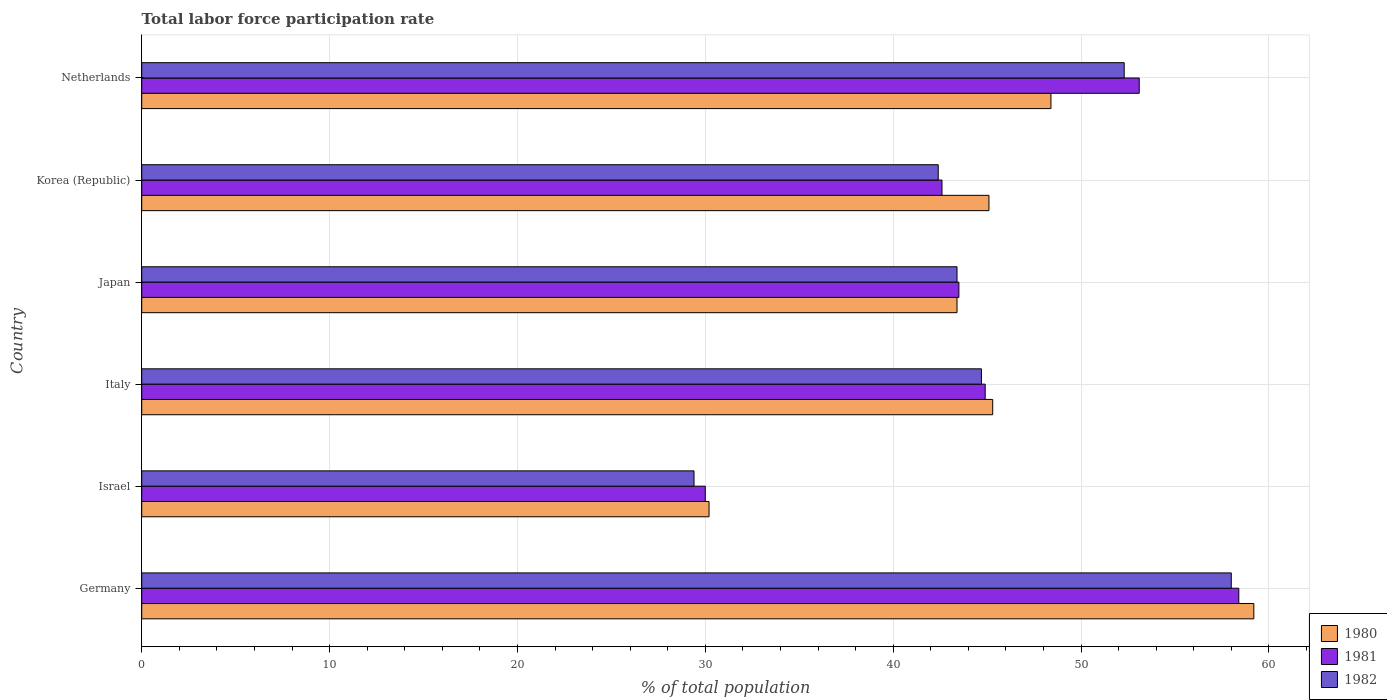How many different coloured bars are there?
Keep it short and to the point. 3. What is the total labor force participation rate in 1982 in Netherlands?
Keep it short and to the point. 52.3. Across all countries, what is the minimum total labor force participation rate in 1980?
Offer a terse response. 30.2. In which country was the total labor force participation rate in 1981 minimum?
Provide a short and direct response. Israel. What is the total total labor force participation rate in 1980 in the graph?
Provide a succinct answer. 271.6. What is the difference between the total labor force participation rate in 1982 in Germany and that in Netherlands?
Keep it short and to the point. 5.7. What is the difference between the total labor force participation rate in 1980 in Israel and the total labor force participation rate in 1982 in Germany?
Your answer should be compact. -27.8. What is the average total labor force participation rate in 1982 per country?
Give a very brief answer. 45.03. What is the difference between the total labor force participation rate in 1982 and total labor force participation rate in 1980 in Israel?
Keep it short and to the point. -0.8. In how many countries, is the total labor force participation rate in 1981 greater than 20 %?
Your response must be concise. 6. What is the ratio of the total labor force participation rate in 1982 in Korea (Republic) to that in Netherlands?
Provide a succinct answer. 0.81. Is the total labor force participation rate in 1981 in Germany less than that in Italy?
Offer a very short reply. No. What is the difference between the highest and the second highest total labor force participation rate in 1981?
Your answer should be compact. 5.3. What is the difference between the highest and the lowest total labor force participation rate in 1982?
Offer a very short reply. 28.6. Is the sum of the total labor force participation rate in 1981 in Germany and Italy greater than the maximum total labor force participation rate in 1980 across all countries?
Keep it short and to the point. Yes. How many countries are there in the graph?
Offer a terse response. 6. Are the values on the major ticks of X-axis written in scientific E-notation?
Your answer should be very brief. No. Does the graph contain any zero values?
Your answer should be compact. No. Where does the legend appear in the graph?
Offer a terse response. Bottom right. How many legend labels are there?
Provide a succinct answer. 3. What is the title of the graph?
Offer a terse response. Total labor force participation rate. What is the label or title of the X-axis?
Offer a terse response. % of total population. What is the % of total population of 1980 in Germany?
Your response must be concise. 59.2. What is the % of total population in 1981 in Germany?
Make the answer very short. 58.4. What is the % of total population of 1980 in Israel?
Provide a succinct answer. 30.2. What is the % of total population in 1982 in Israel?
Your answer should be very brief. 29.4. What is the % of total population in 1980 in Italy?
Make the answer very short. 45.3. What is the % of total population in 1981 in Italy?
Offer a terse response. 44.9. What is the % of total population of 1982 in Italy?
Offer a very short reply. 44.7. What is the % of total population of 1980 in Japan?
Your answer should be compact. 43.4. What is the % of total population in 1981 in Japan?
Provide a short and direct response. 43.5. What is the % of total population of 1982 in Japan?
Make the answer very short. 43.4. What is the % of total population in 1980 in Korea (Republic)?
Ensure brevity in your answer.  45.1. What is the % of total population of 1981 in Korea (Republic)?
Provide a succinct answer. 42.6. What is the % of total population in 1982 in Korea (Republic)?
Your answer should be very brief. 42.4. What is the % of total population of 1980 in Netherlands?
Offer a very short reply. 48.4. What is the % of total population of 1981 in Netherlands?
Provide a succinct answer. 53.1. What is the % of total population of 1982 in Netherlands?
Provide a succinct answer. 52.3. Across all countries, what is the maximum % of total population in 1980?
Offer a terse response. 59.2. Across all countries, what is the maximum % of total population of 1981?
Keep it short and to the point. 58.4. Across all countries, what is the minimum % of total population of 1980?
Your response must be concise. 30.2. Across all countries, what is the minimum % of total population of 1982?
Provide a succinct answer. 29.4. What is the total % of total population of 1980 in the graph?
Provide a short and direct response. 271.6. What is the total % of total population in 1981 in the graph?
Provide a short and direct response. 272.5. What is the total % of total population in 1982 in the graph?
Your answer should be compact. 270.2. What is the difference between the % of total population of 1980 in Germany and that in Israel?
Offer a very short reply. 29. What is the difference between the % of total population in 1981 in Germany and that in Israel?
Keep it short and to the point. 28.4. What is the difference between the % of total population of 1982 in Germany and that in Israel?
Offer a very short reply. 28.6. What is the difference between the % of total population in 1981 in Germany and that in Italy?
Your response must be concise. 13.5. What is the difference between the % of total population of 1982 in Germany and that in Italy?
Offer a very short reply. 13.3. What is the difference between the % of total population in 1981 in Germany and that in Japan?
Your response must be concise. 14.9. What is the difference between the % of total population of 1980 in Germany and that in Korea (Republic)?
Offer a very short reply. 14.1. What is the difference between the % of total population of 1980 in Germany and that in Netherlands?
Your answer should be compact. 10.8. What is the difference between the % of total population in 1981 in Germany and that in Netherlands?
Make the answer very short. 5.3. What is the difference between the % of total population in 1980 in Israel and that in Italy?
Give a very brief answer. -15.1. What is the difference between the % of total population of 1981 in Israel and that in Italy?
Provide a succinct answer. -14.9. What is the difference between the % of total population of 1982 in Israel and that in Italy?
Make the answer very short. -15.3. What is the difference between the % of total population in 1981 in Israel and that in Japan?
Your answer should be very brief. -13.5. What is the difference between the % of total population of 1982 in Israel and that in Japan?
Keep it short and to the point. -14. What is the difference between the % of total population of 1980 in Israel and that in Korea (Republic)?
Provide a short and direct response. -14.9. What is the difference between the % of total population in 1981 in Israel and that in Korea (Republic)?
Your answer should be compact. -12.6. What is the difference between the % of total population of 1980 in Israel and that in Netherlands?
Your response must be concise. -18.2. What is the difference between the % of total population of 1981 in Israel and that in Netherlands?
Your answer should be compact. -23.1. What is the difference between the % of total population of 1982 in Israel and that in Netherlands?
Make the answer very short. -22.9. What is the difference between the % of total population of 1981 in Italy and that in Japan?
Offer a very short reply. 1.4. What is the difference between the % of total population in 1982 in Italy and that in Japan?
Provide a succinct answer. 1.3. What is the difference between the % of total population in 1980 in Italy and that in Korea (Republic)?
Offer a very short reply. 0.2. What is the difference between the % of total population in 1981 in Italy and that in Korea (Republic)?
Make the answer very short. 2.3. What is the difference between the % of total population in 1982 in Italy and that in Korea (Republic)?
Ensure brevity in your answer.  2.3. What is the difference between the % of total population in 1980 in Italy and that in Netherlands?
Give a very brief answer. -3.1. What is the difference between the % of total population in 1981 in Italy and that in Netherlands?
Give a very brief answer. -8.2. What is the difference between the % of total population of 1982 in Japan and that in Korea (Republic)?
Your response must be concise. 1. What is the difference between the % of total population of 1980 in Japan and that in Netherlands?
Your answer should be compact. -5. What is the difference between the % of total population in 1982 in Japan and that in Netherlands?
Make the answer very short. -8.9. What is the difference between the % of total population of 1980 in Germany and the % of total population of 1981 in Israel?
Keep it short and to the point. 29.2. What is the difference between the % of total population in 1980 in Germany and the % of total population in 1982 in Israel?
Your answer should be compact. 29.8. What is the difference between the % of total population in 1980 in Germany and the % of total population in 1981 in Italy?
Your response must be concise. 14.3. What is the difference between the % of total population of 1980 in Germany and the % of total population of 1982 in Italy?
Make the answer very short. 14.5. What is the difference between the % of total population of 1980 in Germany and the % of total population of 1981 in Japan?
Offer a terse response. 15.7. What is the difference between the % of total population of 1980 in Germany and the % of total population of 1982 in Japan?
Ensure brevity in your answer.  15.8. What is the difference between the % of total population in 1980 in Germany and the % of total population in 1981 in Korea (Republic)?
Make the answer very short. 16.6. What is the difference between the % of total population in 1980 in Germany and the % of total population in 1982 in Korea (Republic)?
Provide a succinct answer. 16.8. What is the difference between the % of total population of 1980 in Germany and the % of total population of 1981 in Netherlands?
Ensure brevity in your answer.  6.1. What is the difference between the % of total population in 1980 in Israel and the % of total population in 1981 in Italy?
Provide a short and direct response. -14.7. What is the difference between the % of total population of 1981 in Israel and the % of total population of 1982 in Italy?
Provide a succinct answer. -14.7. What is the difference between the % of total population in 1980 in Israel and the % of total population in 1981 in Japan?
Offer a terse response. -13.3. What is the difference between the % of total population of 1980 in Israel and the % of total population of 1982 in Japan?
Give a very brief answer. -13.2. What is the difference between the % of total population of 1980 in Israel and the % of total population of 1981 in Korea (Republic)?
Your answer should be compact. -12.4. What is the difference between the % of total population in 1981 in Israel and the % of total population in 1982 in Korea (Republic)?
Offer a very short reply. -12.4. What is the difference between the % of total population of 1980 in Israel and the % of total population of 1981 in Netherlands?
Keep it short and to the point. -22.9. What is the difference between the % of total population of 1980 in Israel and the % of total population of 1982 in Netherlands?
Your answer should be very brief. -22.1. What is the difference between the % of total population of 1981 in Israel and the % of total population of 1982 in Netherlands?
Your response must be concise. -22.3. What is the difference between the % of total population of 1980 in Italy and the % of total population of 1982 in Japan?
Provide a short and direct response. 1.9. What is the difference between the % of total population in 1980 in Italy and the % of total population in 1982 in Korea (Republic)?
Offer a very short reply. 2.9. What is the difference between the % of total population of 1980 in Italy and the % of total population of 1981 in Netherlands?
Provide a short and direct response. -7.8. What is the difference between the % of total population in 1981 in Italy and the % of total population in 1982 in Netherlands?
Ensure brevity in your answer.  -7.4. What is the difference between the % of total population in 1980 in Japan and the % of total population in 1982 in Korea (Republic)?
Provide a succinct answer. 1. What is the difference between the % of total population in 1980 in Japan and the % of total population in 1981 in Netherlands?
Make the answer very short. -9.7. What is the difference between the % of total population of 1980 in Japan and the % of total population of 1982 in Netherlands?
Offer a very short reply. -8.9. What is the difference between the % of total population of 1980 in Korea (Republic) and the % of total population of 1982 in Netherlands?
Give a very brief answer. -7.2. What is the difference between the % of total population of 1981 in Korea (Republic) and the % of total population of 1982 in Netherlands?
Offer a terse response. -9.7. What is the average % of total population in 1980 per country?
Provide a succinct answer. 45.27. What is the average % of total population of 1981 per country?
Give a very brief answer. 45.42. What is the average % of total population in 1982 per country?
Ensure brevity in your answer.  45.03. What is the difference between the % of total population of 1980 and % of total population of 1981 in Germany?
Your response must be concise. 0.8. What is the difference between the % of total population in 1980 and % of total population in 1982 in Germany?
Give a very brief answer. 1.2. What is the difference between the % of total population of 1981 and % of total population of 1982 in Germany?
Your answer should be very brief. 0.4. What is the difference between the % of total population in 1980 and % of total population in 1982 in Israel?
Provide a short and direct response. 0.8. What is the difference between the % of total population in 1980 and % of total population in 1981 in Italy?
Provide a short and direct response. 0.4. What is the difference between the % of total population in 1980 and % of total population in 1982 in Italy?
Keep it short and to the point. 0.6. What is the difference between the % of total population of 1980 and % of total population of 1982 in Japan?
Provide a short and direct response. 0. What is the difference between the % of total population in 1980 and % of total population in 1982 in Korea (Republic)?
Provide a short and direct response. 2.7. What is the difference between the % of total population of 1980 and % of total population of 1981 in Netherlands?
Keep it short and to the point. -4.7. What is the ratio of the % of total population in 1980 in Germany to that in Israel?
Your answer should be compact. 1.96. What is the ratio of the % of total population in 1981 in Germany to that in Israel?
Provide a short and direct response. 1.95. What is the ratio of the % of total population of 1982 in Germany to that in Israel?
Keep it short and to the point. 1.97. What is the ratio of the % of total population of 1980 in Germany to that in Italy?
Your answer should be very brief. 1.31. What is the ratio of the % of total population in 1981 in Germany to that in Italy?
Your response must be concise. 1.3. What is the ratio of the % of total population in 1982 in Germany to that in Italy?
Offer a terse response. 1.3. What is the ratio of the % of total population in 1980 in Germany to that in Japan?
Provide a succinct answer. 1.36. What is the ratio of the % of total population of 1981 in Germany to that in Japan?
Provide a short and direct response. 1.34. What is the ratio of the % of total population of 1982 in Germany to that in Japan?
Give a very brief answer. 1.34. What is the ratio of the % of total population in 1980 in Germany to that in Korea (Republic)?
Provide a succinct answer. 1.31. What is the ratio of the % of total population of 1981 in Germany to that in Korea (Republic)?
Your response must be concise. 1.37. What is the ratio of the % of total population in 1982 in Germany to that in Korea (Republic)?
Keep it short and to the point. 1.37. What is the ratio of the % of total population of 1980 in Germany to that in Netherlands?
Keep it short and to the point. 1.22. What is the ratio of the % of total population of 1981 in Germany to that in Netherlands?
Provide a succinct answer. 1.1. What is the ratio of the % of total population of 1982 in Germany to that in Netherlands?
Keep it short and to the point. 1.11. What is the ratio of the % of total population in 1980 in Israel to that in Italy?
Keep it short and to the point. 0.67. What is the ratio of the % of total population in 1981 in Israel to that in Italy?
Make the answer very short. 0.67. What is the ratio of the % of total population of 1982 in Israel to that in Italy?
Give a very brief answer. 0.66. What is the ratio of the % of total population in 1980 in Israel to that in Japan?
Your answer should be very brief. 0.7. What is the ratio of the % of total population of 1981 in Israel to that in Japan?
Offer a terse response. 0.69. What is the ratio of the % of total population of 1982 in Israel to that in Japan?
Ensure brevity in your answer.  0.68. What is the ratio of the % of total population of 1980 in Israel to that in Korea (Republic)?
Your answer should be very brief. 0.67. What is the ratio of the % of total population in 1981 in Israel to that in Korea (Republic)?
Make the answer very short. 0.7. What is the ratio of the % of total population of 1982 in Israel to that in Korea (Republic)?
Your answer should be very brief. 0.69. What is the ratio of the % of total population of 1980 in Israel to that in Netherlands?
Offer a very short reply. 0.62. What is the ratio of the % of total population in 1981 in Israel to that in Netherlands?
Make the answer very short. 0.56. What is the ratio of the % of total population of 1982 in Israel to that in Netherlands?
Give a very brief answer. 0.56. What is the ratio of the % of total population in 1980 in Italy to that in Japan?
Your answer should be compact. 1.04. What is the ratio of the % of total population of 1981 in Italy to that in Japan?
Your answer should be very brief. 1.03. What is the ratio of the % of total population of 1980 in Italy to that in Korea (Republic)?
Your answer should be very brief. 1. What is the ratio of the % of total population in 1981 in Italy to that in Korea (Republic)?
Offer a very short reply. 1.05. What is the ratio of the % of total population of 1982 in Italy to that in Korea (Republic)?
Offer a very short reply. 1.05. What is the ratio of the % of total population of 1980 in Italy to that in Netherlands?
Make the answer very short. 0.94. What is the ratio of the % of total population of 1981 in Italy to that in Netherlands?
Offer a terse response. 0.85. What is the ratio of the % of total population of 1982 in Italy to that in Netherlands?
Provide a short and direct response. 0.85. What is the ratio of the % of total population in 1980 in Japan to that in Korea (Republic)?
Your response must be concise. 0.96. What is the ratio of the % of total population in 1981 in Japan to that in Korea (Republic)?
Your answer should be compact. 1.02. What is the ratio of the % of total population of 1982 in Japan to that in Korea (Republic)?
Make the answer very short. 1.02. What is the ratio of the % of total population of 1980 in Japan to that in Netherlands?
Provide a succinct answer. 0.9. What is the ratio of the % of total population of 1981 in Japan to that in Netherlands?
Provide a succinct answer. 0.82. What is the ratio of the % of total population of 1982 in Japan to that in Netherlands?
Offer a terse response. 0.83. What is the ratio of the % of total population of 1980 in Korea (Republic) to that in Netherlands?
Keep it short and to the point. 0.93. What is the ratio of the % of total population in 1981 in Korea (Republic) to that in Netherlands?
Provide a short and direct response. 0.8. What is the ratio of the % of total population of 1982 in Korea (Republic) to that in Netherlands?
Keep it short and to the point. 0.81. What is the difference between the highest and the second highest % of total population of 1980?
Make the answer very short. 10.8. What is the difference between the highest and the lowest % of total population of 1981?
Provide a succinct answer. 28.4. What is the difference between the highest and the lowest % of total population in 1982?
Offer a terse response. 28.6. 